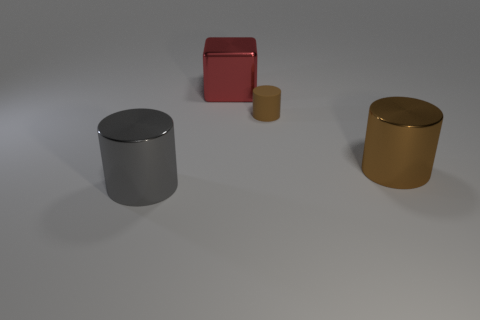Is there any other thing that is the same size as the rubber object?
Ensure brevity in your answer.  No. What is the size of the metallic cylinder on the right side of the cylinder that is in front of the big brown shiny thing?
Offer a very short reply. Large. Do the big metallic cylinder to the left of the red block and the big cylinder that is right of the big red object have the same color?
Give a very brief answer. No. The thing that is right of the red cube and behind the brown metal cylinder is what color?
Provide a short and direct response. Brown. What number of other things are there of the same shape as the small thing?
Provide a succinct answer. 2. What color is the other cylinder that is the same size as the gray metal cylinder?
Your answer should be compact. Brown. There is a cylinder to the right of the tiny matte cylinder; what color is it?
Ensure brevity in your answer.  Brown. There is a small cylinder behind the gray metal cylinder; is there a brown cylinder in front of it?
Provide a short and direct response. Yes. There is a small brown thing; is it the same shape as the big metal thing on the right side of the block?
Offer a terse response. Yes. There is a thing that is both in front of the tiny brown thing and right of the large red metallic object; what is its size?
Offer a terse response. Large. 